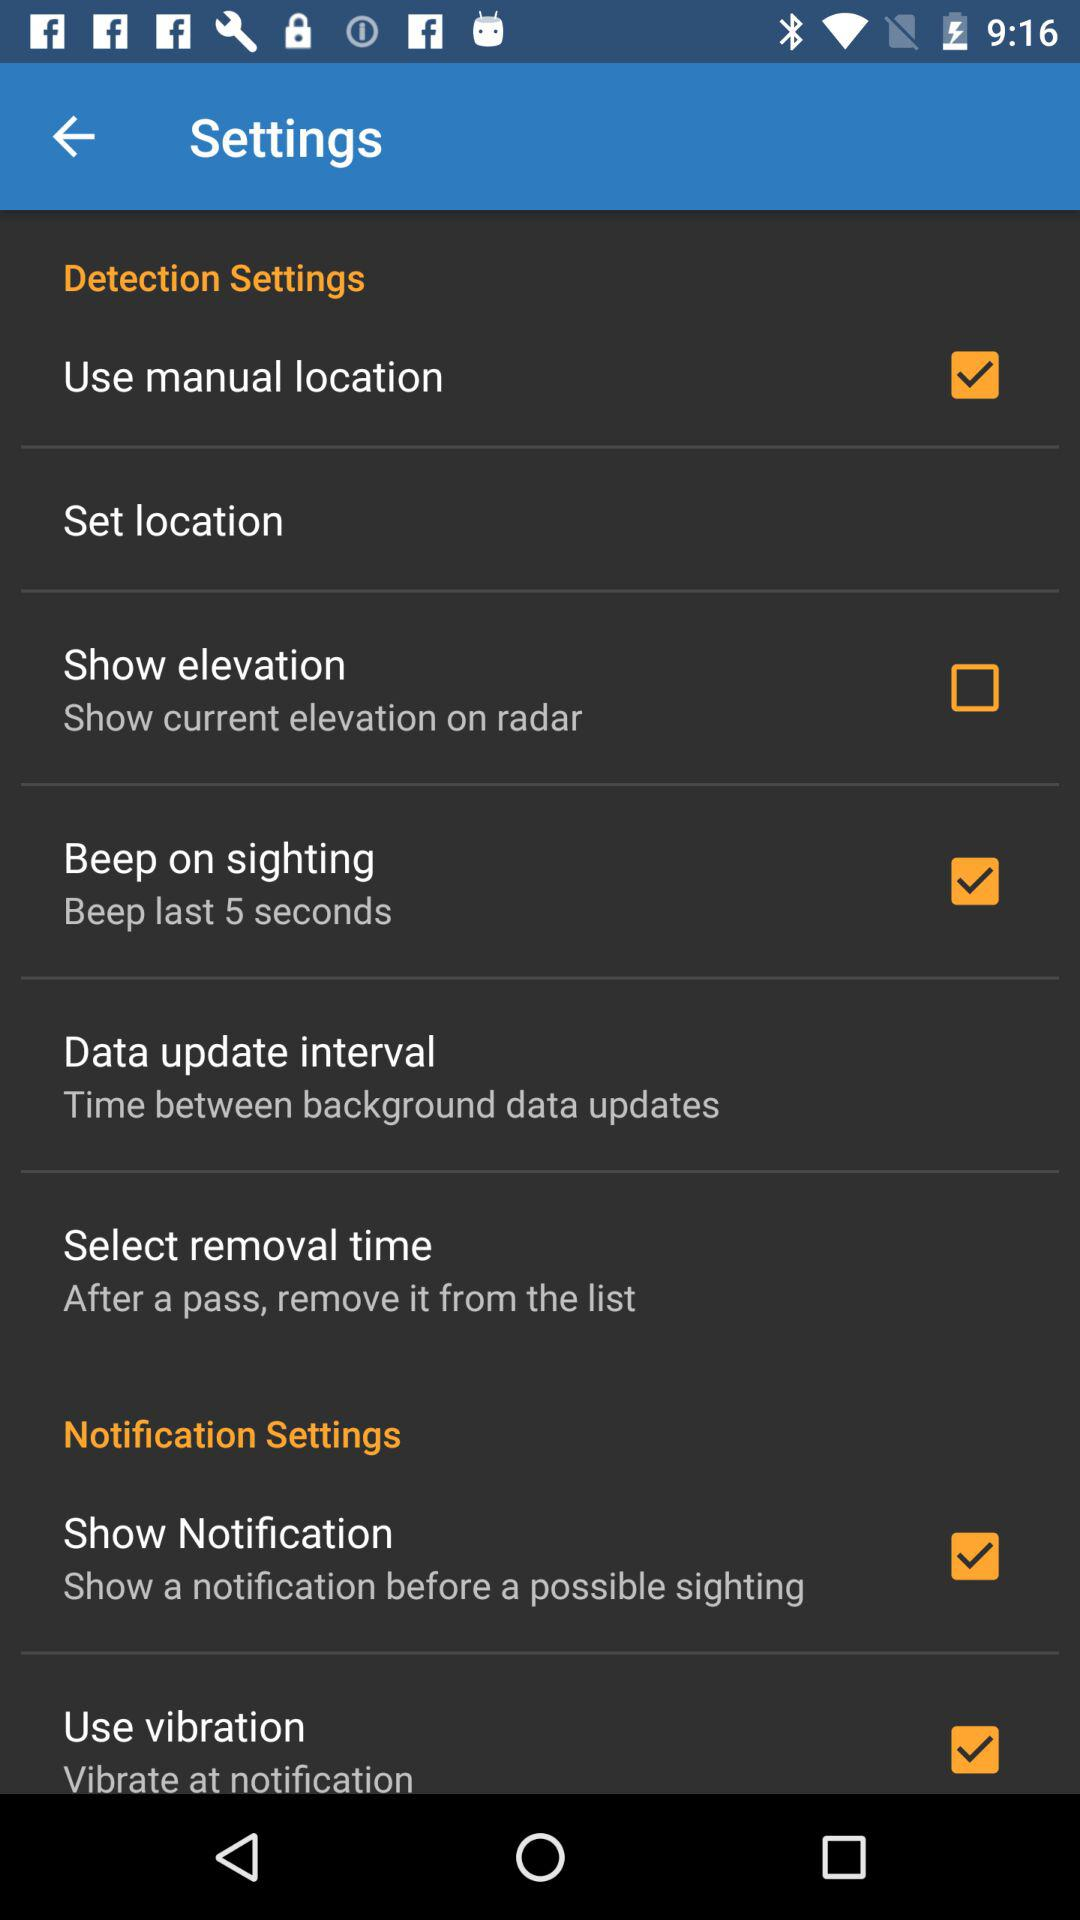What is the status of "Show notifications"? The status is "on". 